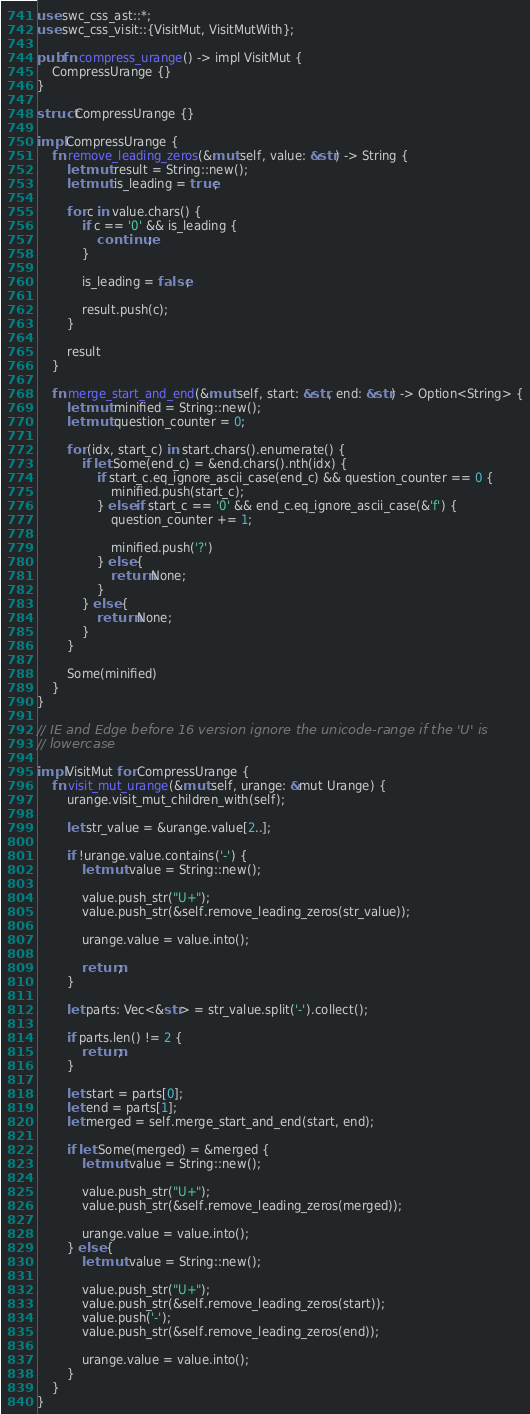<code> <loc_0><loc_0><loc_500><loc_500><_Rust_>use swc_css_ast::*;
use swc_css_visit::{VisitMut, VisitMutWith};

pub fn compress_urange() -> impl VisitMut {
    CompressUrange {}
}

struct CompressUrange {}

impl CompressUrange {
    fn remove_leading_zeros(&mut self, value: &str) -> String {
        let mut result = String::new();
        let mut is_leading = true;

        for c in value.chars() {
            if c == '0' && is_leading {
                continue;
            }

            is_leading = false;

            result.push(c);
        }

        result
    }

    fn merge_start_and_end(&mut self, start: &str, end: &str) -> Option<String> {
        let mut minified = String::new();
        let mut question_counter = 0;

        for (idx, start_c) in start.chars().enumerate() {
            if let Some(end_c) = &end.chars().nth(idx) {
                if start_c.eq_ignore_ascii_case(end_c) && question_counter == 0 {
                    minified.push(start_c);
                } else if start_c == '0' && end_c.eq_ignore_ascii_case(&'f') {
                    question_counter += 1;

                    minified.push('?')
                } else {
                    return None;
                }
            } else {
                return None;
            }
        }

        Some(minified)
    }
}

// IE and Edge before 16 version ignore the unicode-range if the 'U' is
// lowercase

impl VisitMut for CompressUrange {
    fn visit_mut_urange(&mut self, urange: &mut Urange) {
        urange.visit_mut_children_with(self);

        let str_value = &urange.value[2..];

        if !urange.value.contains('-') {
            let mut value = String::new();

            value.push_str("U+");
            value.push_str(&self.remove_leading_zeros(str_value));

            urange.value = value.into();

            return;
        }

        let parts: Vec<&str> = str_value.split('-').collect();

        if parts.len() != 2 {
            return;
        }

        let start = parts[0];
        let end = parts[1];
        let merged = self.merge_start_and_end(start, end);

        if let Some(merged) = &merged {
            let mut value = String::new();

            value.push_str("U+");
            value.push_str(&self.remove_leading_zeros(merged));

            urange.value = value.into();
        } else {
            let mut value = String::new();

            value.push_str("U+");
            value.push_str(&self.remove_leading_zeros(start));
            value.push('-');
            value.push_str(&self.remove_leading_zeros(end));

            urange.value = value.into();
        }
    }
}
</code> 